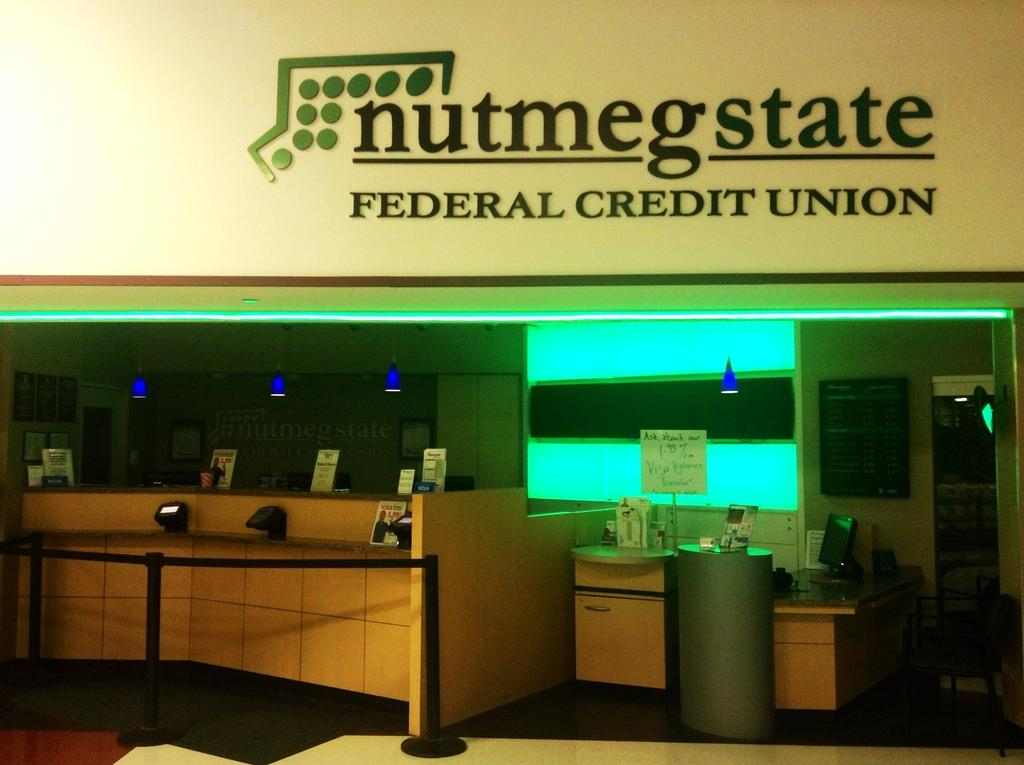<image>
Create a compact narrative representing the image presented. The office shown is that of the Federal Credit Union. 